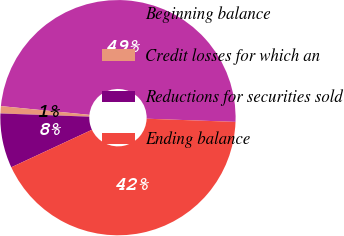<chart> <loc_0><loc_0><loc_500><loc_500><pie_chart><fcel>Beginning balance<fcel>Credit losses for which an<fcel>Reductions for securities sold<fcel>Ending balance<nl><fcel>49.0%<fcel>1.0%<fcel>7.5%<fcel>42.5%<nl></chart> 